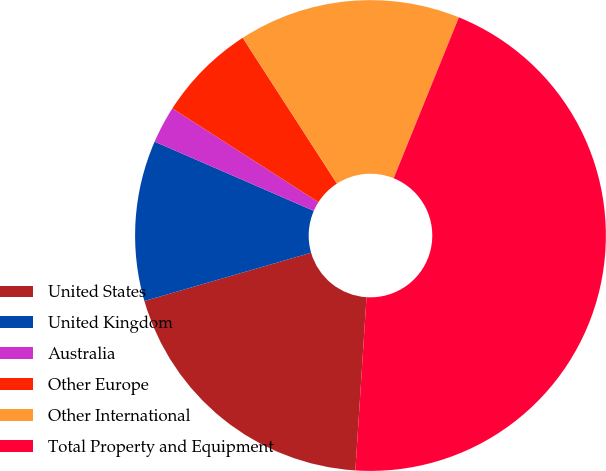Convert chart to OTSL. <chart><loc_0><loc_0><loc_500><loc_500><pie_chart><fcel>United States<fcel>United Kingdom<fcel>Australia<fcel>Other Europe<fcel>Other International<fcel>Total Property and Equipment<nl><fcel>19.49%<fcel>11.02%<fcel>2.55%<fcel>6.79%<fcel>15.26%<fcel>44.9%<nl></chart> 